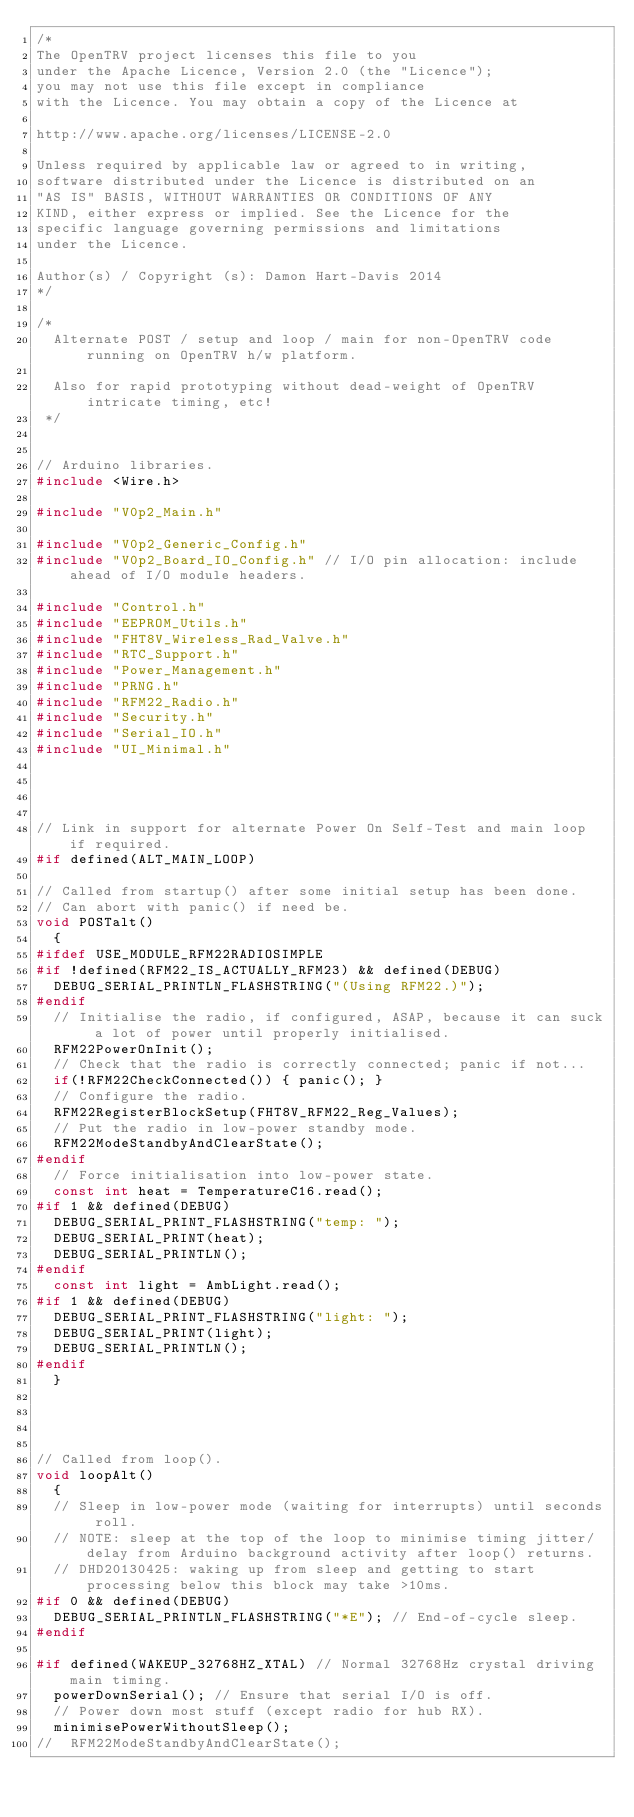Convert code to text. <code><loc_0><loc_0><loc_500><loc_500><_C++_>/*
The OpenTRV project licenses this file to you
under the Apache Licence, Version 2.0 (the "Licence");
you may not use this file except in compliance
with the Licence. You may obtain a copy of the Licence at

http://www.apache.org/licenses/LICENSE-2.0

Unless required by applicable law or agreed to in writing,
software distributed under the Licence is distributed on an
"AS IS" BASIS, WITHOUT WARRANTIES OR CONDITIONS OF ANY
KIND, either express or implied. See the Licence for the
specific language governing permissions and limitations
under the Licence.

Author(s) / Copyright (s): Damon Hart-Davis 2014
*/

/*
  Alternate POST / setup and loop / main for non-OpenTRV code running on OpenTRV h/w platform.

  Also for rapid prototyping without dead-weight of OpenTRV intricate timing, etc!
 */


// Arduino libraries.
#include <Wire.h>

#include "V0p2_Main.h"

#include "V0p2_Generic_Config.h"
#include "V0p2_Board_IO_Config.h" // I/O pin allocation: include ahead of I/O module headers.

#include "Control.h"
#include "EEPROM_Utils.h"
#include "FHT8V_Wireless_Rad_Valve.h"
#include "RTC_Support.h"
#include "Power_Management.h"
#include "PRNG.h"
#include "RFM22_Radio.h"
#include "Security.h"
#include "Serial_IO.h"
#include "UI_Minimal.h"




// Link in support for alternate Power On Self-Test and main loop if required.
#if defined(ALT_MAIN_LOOP)

// Called from startup() after some initial setup has been done.
// Can abort with panic() if need be.
void POSTalt()
  {
#ifdef USE_MODULE_RFM22RADIOSIMPLE
#if !defined(RFM22_IS_ACTUALLY_RFM23) && defined(DEBUG)
  DEBUG_SERIAL_PRINTLN_FLASHSTRING("(Using RFM22.)");
#endif
  // Initialise the radio, if configured, ASAP, because it can suck a lot of power until properly initialised.
  RFM22PowerOnInit();
  // Check that the radio is correctly connected; panic if not...
  if(!RFM22CheckConnected()) { panic(); }
  // Configure the radio.
  RFM22RegisterBlockSetup(FHT8V_RFM22_Reg_Values);
  // Put the radio in low-power standby mode.
  RFM22ModeStandbyAndClearState();
#endif
  // Force initialisation into low-power state.
  const int heat = TemperatureC16.read();
#if 1 && defined(DEBUG)
  DEBUG_SERIAL_PRINT_FLASHSTRING("temp: ");
  DEBUG_SERIAL_PRINT(heat);
  DEBUG_SERIAL_PRINTLN();
#endif
  const int light = AmbLight.read();
#if 1 && defined(DEBUG)
  DEBUG_SERIAL_PRINT_FLASHSTRING("light: ");
  DEBUG_SERIAL_PRINT(light);
  DEBUG_SERIAL_PRINTLN();
#endif
  }




// Called from loop().
void loopAlt()
  {
  // Sleep in low-power mode (waiting for interrupts) until seconds roll.
  // NOTE: sleep at the top of the loop to minimise timing jitter/delay from Arduino background activity after loop() returns.
  // DHD20130425: waking up from sleep and getting to start processing below this block may take >10ms.
#if 0 && defined(DEBUG)
  DEBUG_SERIAL_PRINTLN_FLASHSTRING("*E"); // End-of-cycle sleep.
#endif

#if defined(WAKEUP_32768HZ_XTAL) // Normal 32768Hz crystal driving main timing.
  powerDownSerial(); // Ensure that serial I/O is off.
  // Power down most stuff (except radio for hub RX).
  minimisePowerWithoutSleep();
//  RFM22ModeStandbyAndClearState();</code> 